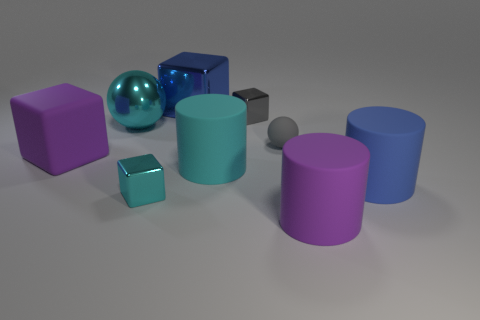Can you tell me about the lighting in this scene? The lighting in the scene appears to be diffused, coming from above. Shadows are cast beneath the objects, suggesting a single light source overhead. The reflections on the shiny surfaces of some objects indicate the environment is not fully represented in the scene. 